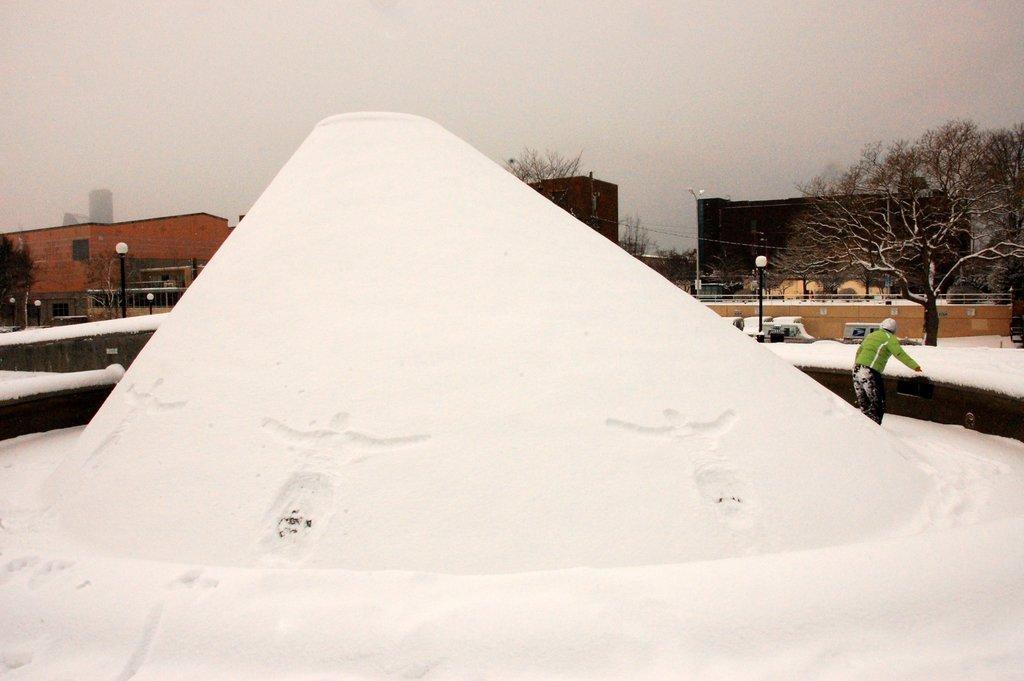How would you summarize this image in a sentence or two? This is snow and there is a person. Here we can see poles, lights, trees, and buildings. In the background there is sky. 